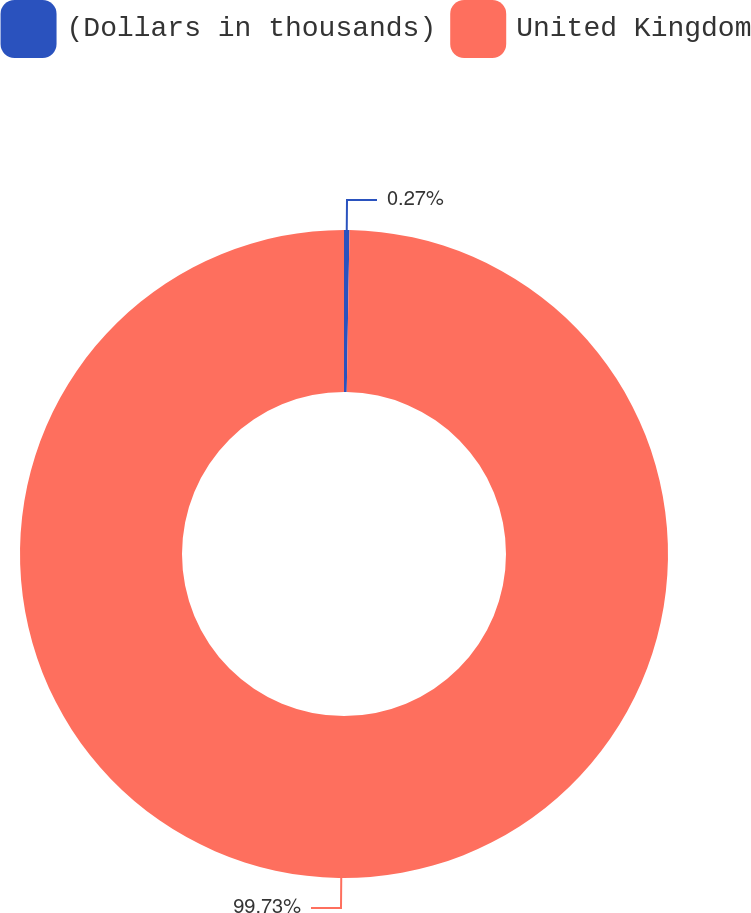Convert chart to OTSL. <chart><loc_0><loc_0><loc_500><loc_500><pie_chart><fcel>(Dollars in thousands)<fcel>United Kingdom<nl><fcel>0.27%<fcel>99.73%<nl></chart> 